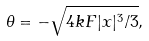Convert formula to latex. <formula><loc_0><loc_0><loc_500><loc_500>\theta = - \sqrt { 4 k F | x | ^ { 3 } / 3 } ,</formula> 